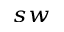<formula> <loc_0><loc_0><loc_500><loc_500>_ { s w }</formula> 